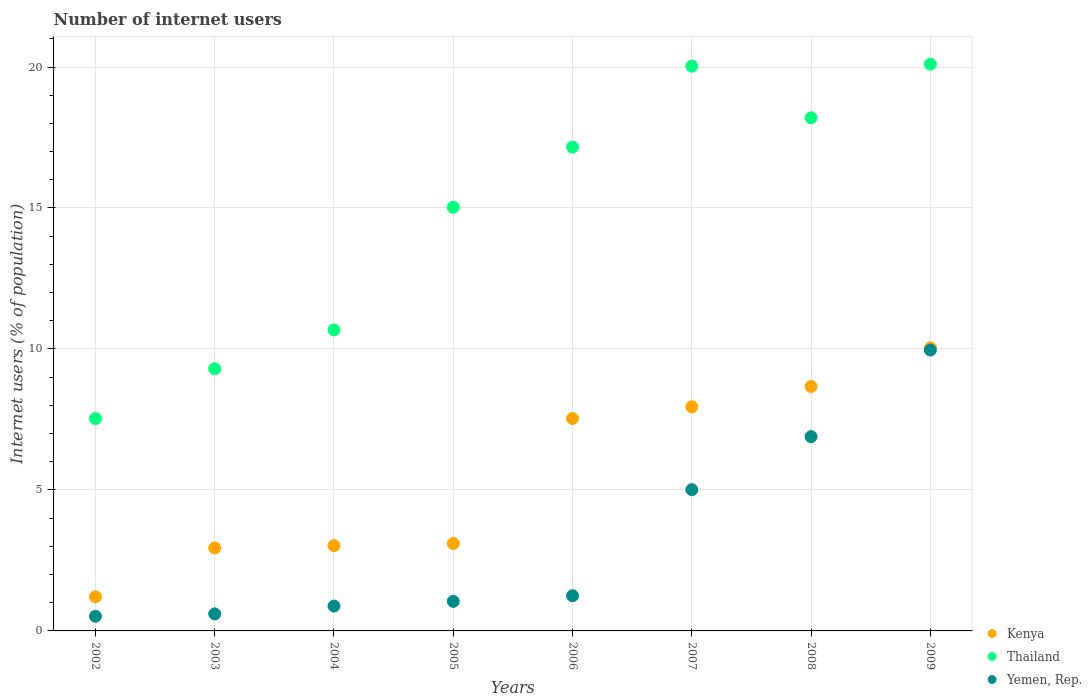How many different coloured dotlines are there?
Give a very brief answer. 3. Is the number of dotlines equal to the number of legend labels?
Ensure brevity in your answer.  Yes. What is the number of internet users in Kenya in 2009?
Your response must be concise. 10.04. Across all years, what is the maximum number of internet users in Kenya?
Your answer should be compact. 10.04. Across all years, what is the minimum number of internet users in Thailand?
Your answer should be compact. 7.53. What is the total number of internet users in Thailand in the graph?
Give a very brief answer. 118.02. What is the difference between the number of internet users in Yemen, Rep. in 2004 and that in 2007?
Provide a short and direct response. -4.13. What is the difference between the number of internet users in Thailand in 2009 and the number of internet users in Yemen, Rep. in 2007?
Your answer should be compact. 15.09. What is the average number of internet users in Yemen, Rep. per year?
Keep it short and to the point. 3.27. In the year 2008, what is the difference between the number of internet users in Yemen, Rep. and number of internet users in Kenya?
Your answer should be very brief. -1.78. What is the ratio of the number of internet users in Yemen, Rep. in 2007 to that in 2008?
Keep it short and to the point. 0.73. Is the number of internet users in Yemen, Rep. in 2007 less than that in 2008?
Offer a terse response. Yes. Is the difference between the number of internet users in Yemen, Rep. in 2007 and 2008 greater than the difference between the number of internet users in Kenya in 2007 and 2008?
Offer a very short reply. No. What is the difference between the highest and the second highest number of internet users in Yemen, Rep.?
Provide a succinct answer. 3.07. What is the difference between the highest and the lowest number of internet users in Yemen, Rep.?
Offer a very short reply. 9.44. In how many years, is the number of internet users in Thailand greater than the average number of internet users in Thailand taken over all years?
Ensure brevity in your answer.  5. Does the number of internet users in Thailand monotonically increase over the years?
Provide a succinct answer. No. Is the number of internet users in Yemen, Rep. strictly greater than the number of internet users in Kenya over the years?
Your answer should be compact. No. Is the number of internet users in Thailand strictly less than the number of internet users in Kenya over the years?
Your response must be concise. No. How many dotlines are there?
Make the answer very short. 3. How many years are there in the graph?
Ensure brevity in your answer.  8. What is the difference between two consecutive major ticks on the Y-axis?
Your answer should be very brief. 5. Does the graph contain any zero values?
Offer a terse response. No. Where does the legend appear in the graph?
Your response must be concise. Bottom right. What is the title of the graph?
Provide a succinct answer. Number of internet users. What is the label or title of the X-axis?
Provide a short and direct response. Years. What is the label or title of the Y-axis?
Your answer should be very brief. Internet users (% of population). What is the Internet users (% of population) of Kenya in 2002?
Provide a succinct answer. 1.21. What is the Internet users (% of population) in Thailand in 2002?
Your answer should be very brief. 7.53. What is the Internet users (% of population) of Yemen, Rep. in 2002?
Your response must be concise. 0.52. What is the Internet users (% of population) in Kenya in 2003?
Your answer should be compact. 2.94. What is the Internet users (% of population) in Thailand in 2003?
Offer a very short reply. 9.3. What is the Internet users (% of population) in Yemen, Rep. in 2003?
Your answer should be compact. 0.6. What is the Internet users (% of population) of Kenya in 2004?
Provide a succinct answer. 3.02. What is the Internet users (% of population) of Thailand in 2004?
Give a very brief answer. 10.68. What is the Internet users (% of population) in Yemen, Rep. in 2004?
Keep it short and to the point. 0.88. What is the Internet users (% of population) of Kenya in 2005?
Your answer should be very brief. 3.1. What is the Internet users (% of population) in Thailand in 2005?
Keep it short and to the point. 15.03. What is the Internet users (% of population) of Yemen, Rep. in 2005?
Give a very brief answer. 1.05. What is the Internet users (% of population) in Kenya in 2006?
Your answer should be very brief. 7.53. What is the Internet users (% of population) in Thailand in 2006?
Provide a succinct answer. 17.16. What is the Internet users (% of population) of Yemen, Rep. in 2006?
Give a very brief answer. 1.25. What is the Internet users (% of population) in Kenya in 2007?
Your answer should be compact. 7.95. What is the Internet users (% of population) of Thailand in 2007?
Your answer should be compact. 20.03. What is the Internet users (% of population) in Yemen, Rep. in 2007?
Ensure brevity in your answer.  5.01. What is the Internet users (% of population) in Kenya in 2008?
Your response must be concise. 8.67. What is the Internet users (% of population) in Yemen, Rep. in 2008?
Keep it short and to the point. 6.89. What is the Internet users (% of population) in Kenya in 2009?
Provide a short and direct response. 10.04. What is the Internet users (% of population) in Thailand in 2009?
Offer a terse response. 20.1. What is the Internet users (% of population) in Yemen, Rep. in 2009?
Provide a succinct answer. 9.96. Across all years, what is the maximum Internet users (% of population) of Kenya?
Provide a succinct answer. 10.04. Across all years, what is the maximum Internet users (% of population) in Thailand?
Your answer should be very brief. 20.1. Across all years, what is the maximum Internet users (% of population) of Yemen, Rep.?
Make the answer very short. 9.96. Across all years, what is the minimum Internet users (% of population) in Kenya?
Your answer should be very brief. 1.21. Across all years, what is the minimum Internet users (% of population) of Thailand?
Provide a succinct answer. 7.53. Across all years, what is the minimum Internet users (% of population) in Yemen, Rep.?
Provide a succinct answer. 0.52. What is the total Internet users (% of population) of Kenya in the graph?
Ensure brevity in your answer.  44.47. What is the total Internet users (% of population) in Thailand in the graph?
Ensure brevity in your answer.  118.02. What is the total Internet users (% of population) in Yemen, Rep. in the graph?
Your answer should be compact. 26.16. What is the difference between the Internet users (% of population) of Kenya in 2002 and that in 2003?
Offer a terse response. -1.73. What is the difference between the Internet users (% of population) of Thailand in 2002 and that in 2003?
Offer a very short reply. -1.77. What is the difference between the Internet users (% of population) of Yemen, Rep. in 2002 and that in 2003?
Provide a succinct answer. -0.09. What is the difference between the Internet users (% of population) in Kenya in 2002 and that in 2004?
Your response must be concise. -1.82. What is the difference between the Internet users (% of population) of Thailand in 2002 and that in 2004?
Ensure brevity in your answer.  -3.15. What is the difference between the Internet users (% of population) of Yemen, Rep. in 2002 and that in 2004?
Keep it short and to the point. -0.36. What is the difference between the Internet users (% of population) in Kenya in 2002 and that in 2005?
Provide a succinct answer. -1.89. What is the difference between the Internet users (% of population) in Thailand in 2002 and that in 2005?
Make the answer very short. -7.49. What is the difference between the Internet users (% of population) in Yemen, Rep. in 2002 and that in 2005?
Your answer should be very brief. -0.53. What is the difference between the Internet users (% of population) in Kenya in 2002 and that in 2006?
Your answer should be compact. -6.33. What is the difference between the Internet users (% of population) of Thailand in 2002 and that in 2006?
Provide a succinct answer. -9.63. What is the difference between the Internet users (% of population) in Yemen, Rep. in 2002 and that in 2006?
Ensure brevity in your answer.  -0.73. What is the difference between the Internet users (% of population) in Kenya in 2002 and that in 2007?
Provide a short and direct response. -6.74. What is the difference between the Internet users (% of population) in Thailand in 2002 and that in 2007?
Offer a very short reply. -12.5. What is the difference between the Internet users (% of population) in Yemen, Rep. in 2002 and that in 2007?
Your answer should be compact. -4.49. What is the difference between the Internet users (% of population) of Kenya in 2002 and that in 2008?
Make the answer very short. -7.46. What is the difference between the Internet users (% of population) in Thailand in 2002 and that in 2008?
Your answer should be very brief. -10.67. What is the difference between the Internet users (% of population) in Yemen, Rep. in 2002 and that in 2008?
Your response must be concise. -6.37. What is the difference between the Internet users (% of population) of Kenya in 2002 and that in 2009?
Give a very brief answer. -8.83. What is the difference between the Internet users (% of population) in Thailand in 2002 and that in 2009?
Provide a short and direct response. -12.57. What is the difference between the Internet users (% of population) of Yemen, Rep. in 2002 and that in 2009?
Keep it short and to the point. -9.44. What is the difference between the Internet users (% of population) of Kenya in 2003 and that in 2004?
Your answer should be very brief. -0.08. What is the difference between the Internet users (% of population) of Thailand in 2003 and that in 2004?
Give a very brief answer. -1.38. What is the difference between the Internet users (% of population) in Yemen, Rep. in 2003 and that in 2004?
Make the answer very short. -0.28. What is the difference between the Internet users (% of population) of Kenya in 2003 and that in 2005?
Keep it short and to the point. -0.16. What is the difference between the Internet users (% of population) in Thailand in 2003 and that in 2005?
Make the answer very short. -5.73. What is the difference between the Internet users (% of population) of Yemen, Rep. in 2003 and that in 2005?
Your response must be concise. -0.44. What is the difference between the Internet users (% of population) of Kenya in 2003 and that in 2006?
Ensure brevity in your answer.  -4.59. What is the difference between the Internet users (% of population) of Thailand in 2003 and that in 2006?
Give a very brief answer. -7.86. What is the difference between the Internet users (% of population) in Yemen, Rep. in 2003 and that in 2006?
Keep it short and to the point. -0.64. What is the difference between the Internet users (% of population) in Kenya in 2003 and that in 2007?
Ensure brevity in your answer.  -5.01. What is the difference between the Internet users (% of population) in Thailand in 2003 and that in 2007?
Offer a terse response. -10.73. What is the difference between the Internet users (% of population) of Yemen, Rep. in 2003 and that in 2007?
Your response must be concise. -4.41. What is the difference between the Internet users (% of population) in Kenya in 2003 and that in 2008?
Your answer should be very brief. -5.73. What is the difference between the Internet users (% of population) in Thailand in 2003 and that in 2008?
Ensure brevity in your answer.  -8.9. What is the difference between the Internet users (% of population) of Yemen, Rep. in 2003 and that in 2008?
Provide a succinct answer. -6.29. What is the difference between the Internet users (% of population) of Kenya in 2003 and that in 2009?
Your response must be concise. -7.1. What is the difference between the Internet users (% of population) in Thailand in 2003 and that in 2009?
Give a very brief answer. -10.8. What is the difference between the Internet users (% of population) in Yemen, Rep. in 2003 and that in 2009?
Ensure brevity in your answer.  -9.36. What is the difference between the Internet users (% of population) in Kenya in 2004 and that in 2005?
Provide a short and direct response. -0.08. What is the difference between the Internet users (% of population) of Thailand in 2004 and that in 2005?
Keep it short and to the point. -4.35. What is the difference between the Internet users (% of population) in Yemen, Rep. in 2004 and that in 2005?
Keep it short and to the point. -0.17. What is the difference between the Internet users (% of population) of Kenya in 2004 and that in 2006?
Offer a very short reply. -4.51. What is the difference between the Internet users (% of population) of Thailand in 2004 and that in 2006?
Ensure brevity in your answer.  -6.48. What is the difference between the Internet users (% of population) in Yemen, Rep. in 2004 and that in 2006?
Make the answer very short. -0.37. What is the difference between the Internet users (% of population) in Kenya in 2004 and that in 2007?
Make the answer very short. -4.93. What is the difference between the Internet users (% of population) in Thailand in 2004 and that in 2007?
Your answer should be compact. -9.35. What is the difference between the Internet users (% of population) in Yemen, Rep. in 2004 and that in 2007?
Your answer should be compact. -4.13. What is the difference between the Internet users (% of population) of Kenya in 2004 and that in 2008?
Ensure brevity in your answer.  -5.65. What is the difference between the Internet users (% of population) in Thailand in 2004 and that in 2008?
Your answer should be compact. -7.52. What is the difference between the Internet users (% of population) of Yemen, Rep. in 2004 and that in 2008?
Keep it short and to the point. -6.01. What is the difference between the Internet users (% of population) in Kenya in 2004 and that in 2009?
Offer a very short reply. -7.02. What is the difference between the Internet users (% of population) in Thailand in 2004 and that in 2009?
Keep it short and to the point. -9.42. What is the difference between the Internet users (% of population) in Yemen, Rep. in 2004 and that in 2009?
Ensure brevity in your answer.  -9.08. What is the difference between the Internet users (% of population) in Kenya in 2005 and that in 2006?
Provide a succinct answer. -4.43. What is the difference between the Internet users (% of population) of Thailand in 2005 and that in 2006?
Provide a short and direct response. -2.13. What is the difference between the Internet users (% of population) in Yemen, Rep. in 2005 and that in 2006?
Provide a short and direct response. -0.2. What is the difference between the Internet users (% of population) of Kenya in 2005 and that in 2007?
Give a very brief answer. -4.85. What is the difference between the Internet users (% of population) in Thailand in 2005 and that in 2007?
Offer a terse response. -5. What is the difference between the Internet users (% of population) in Yemen, Rep. in 2005 and that in 2007?
Ensure brevity in your answer.  -3.96. What is the difference between the Internet users (% of population) in Kenya in 2005 and that in 2008?
Provide a short and direct response. -5.57. What is the difference between the Internet users (% of population) in Thailand in 2005 and that in 2008?
Provide a succinct answer. -3.17. What is the difference between the Internet users (% of population) in Yemen, Rep. in 2005 and that in 2008?
Offer a very short reply. -5.84. What is the difference between the Internet users (% of population) in Kenya in 2005 and that in 2009?
Provide a succinct answer. -6.94. What is the difference between the Internet users (% of population) in Thailand in 2005 and that in 2009?
Offer a terse response. -5.07. What is the difference between the Internet users (% of population) in Yemen, Rep. in 2005 and that in 2009?
Give a very brief answer. -8.91. What is the difference between the Internet users (% of population) in Kenya in 2006 and that in 2007?
Provide a succinct answer. -0.42. What is the difference between the Internet users (% of population) of Thailand in 2006 and that in 2007?
Your answer should be very brief. -2.87. What is the difference between the Internet users (% of population) in Yemen, Rep. in 2006 and that in 2007?
Your answer should be compact. -3.76. What is the difference between the Internet users (% of population) of Kenya in 2006 and that in 2008?
Offer a very short reply. -1.14. What is the difference between the Internet users (% of population) in Thailand in 2006 and that in 2008?
Keep it short and to the point. -1.04. What is the difference between the Internet users (% of population) in Yemen, Rep. in 2006 and that in 2008?
Ensure brevity in your answer.  -5.64. What is the difference between the Internet users (% of population) of Kenya in 2006 and that in 2009?
Give a very brief answer. -2.51. What is the difference between the Internet users (% of population) of Thailand in 2006 and that in 2009?
Ensure brevity in your answer.  -2.94. What is the difference between the Internet users (% of population) of Yemen, Rep. in 2006 and that in 2009?
Provide a short and direct response. -8.71. What is the difference between the Internet users (% of population) of Kenya in 2007 and that in 2008?
Offer a terse response. -0.72. What is the difference between the Internet users (% of population) in Thailand in 2007 and that in 2008?
Give a very brief answer. 1.83. What is the difference between the Internet users (% of population) in Yemen, Rep. in 2007 and that in 2008?
Make the answer very short. -1.88. What is the difference between the Internet users (% of population) of Kenya in 2007 and that in 2009?
Offer a terse response. -2.09. What is the difference between the Internet users (% of population) in Thailand in 2007 and that in 2009?
Provide a succinct answer. -0.07. What is the difference between the Internet users (% of population) of Yemen, Rep. in 2007 and that in 2009?
Offer a terse response. -4.95. What is the difference between the Internet users (% of population) of Kenya in 2008 and that in 2009?
Ensure brevity in your answer.  -1.37. What is the difference between the Internet users (% of population) of Thailand in 2008 and that in 2009?
Make the answer very short. -1.9. What is the difference between the Internet users (% of population) in Yemen, Rep. in 2008 and that in 2009?
Provide a succinct answer. -3.07. What is the difference between the Internet users (% of population) in Kenya in 2002 and the Internet users (% of population) in Thailand in 2003?
Offer a very short reply. -8.09. What is the difference between the Internet users (% of population) of Kenya in 2002 and the Internet users (% of population) of Yemen, Rep. in 2003?
Ensure brevity in your answer.  0.6. What is the difference between the Internet users (% of population) of Thailand in 2002 and the Internet users (% of population) of Yemen, Rep. in 2003?
Offer a very short reply. 6.93. What is the difference between the Internet users (% of population) in Kenya in 2002 and the Internet users (% of population) in Thailand in 2004?
Ensure brevity in your answer.  -9.47. What is the difference between the Internet users (% of population) in Kenya in 2002 and the Internet users (% of population) in Yemen, Rep. in 2004?
Make the answer very short. 0.33. What is the difference between the Internet users (% of population) of Thailand in 2002 and the Internet users (% of population) of Yemen, Rep. in 2004?
Your answer should be very brief. 6.65. What is the difference between the Internet users (% of population) in Kenya in 2002 and the Internet users (% of population) in Thailand in 2005?
Offer a terse response. -13.82. What is the difference between the Internet users (% of population) of Kenya in 2002 and the Internet users (% of population) of Yemen, Rep. in 2005?
Ensure brevity in your answer.  0.16. What is the difference between the Internet users (% of population) in Thailand in 2002 and the Internet users (% of population) in Yemen, Rep. in 2005?
Your answer should be compact. 6.48. What is the difference between the Internet users (% of population) of Kenya in 2002 and the Internet users (% of population) of Thailand in 2006?
Your answer should be very brief. -15.95. What is the difference between the Internet users (% of population) of Kenya in 2002 and the Internet users (% of population) of Yemen, Rep. in 2006?
Offer a very short reply. -0.04. What is the difference between the Internet users (% of population) in Thailand in 2002 and the Internet users (% of population) in Yemen, Rep. in 2006?
Ensure brevity in your answer.  6.28. What is the difference between the Internet users (% of population) of Kenya in 2002 and the Internet users (% of population) of Thailand in 2007?
Make the answer very short. -18.82. What is the difference between the Internet users (% of population) in Kenya in 2002 and the Internet users (% of population) in Yemen, Rep. in 2007?
Make the answer very short. -3.8. What is the difference between the Internet users (% of population) of Thailand in 2002 and the Internet users (% of population) of Yemen, Rep. in 2007?
Your response must be concise. 2.52. What is the difference between the Internet users (% of population) of Kenya in 2002 and the Internet users (% of population) of Thailand in 2008?
Your answer should be very brief. -16.99. What is the difference between the Internet users (% of population) in Kenya in 2002 and the Internet users (% of population) in Yemen, Rep. in 2008?
Provide a short and direct response. -5.68. What is the difference between the Internet users (% of population) in Thailand in 2002 and the Internet users (% of population) in Yemen, Rep. in 2008?
Offer a terse response. 0.64. What is the difference between the Internet users (% of population) of Kenya in 2002 and the Internet users (% of population) of Thailand in 2009?
Provide a short and direct response. -18.89. What is the difference between the Internet users (% of population) of Kenya in 2002 and the Internet users (% of population) of Yemen, Rep. in 2009?
Provide a short and direct response. -8.75. What is the difference between the Internet users (% of population) in Thailand in 2002 and the Internet users (% of population) in Yemen, Rep. in 2009?
Your answer should be very brief. -2.43. What is the difference between the Internet users (% of population) of Kenya in 2003 and the Internet users (% of population) of Thailand in 2004?
Your answer should be very brief. -7.74. What is the difference between the Internet users (% of population) of Kenya in 2003 and the Internet users (% of population) of Yemen, Rep. in 2004?
Ensure brevity in your answer.  2.06. What is the difference between the Internet users (% of population) in Thailand in 2003 and the Internet users (% of population) in Yemen, Rep. in 2004?
Your answer should be very brief. 8.42. What is the difference between the Internet users (% of population) in Kenya in 2003 and the Internet users (% of population) in Thailand in 2005?
Make the answer very short. -12.08. What is the difference between the Internet users (% of population) in Kenya in 2003 and the Internet users (% of population) in Yemen, Rep. in 2005?
Make the answer very short. 1.89. What is the difference between the Internet users (% of population) of Thailand in 2003 and the Internet users (% of population) of Yemen, Rep. in 2005?
Your response must be concise. 8.25. What is the difference between the Internet users (% of population) of Kenya in 2003 and the Internet users (% of population) of Thailand in 2006?
Ensure brevity in your answer.  -14.22. What is the difference between the Internet users (% of population) in Kenya in 2003 and the Internet users (% of population) in Yemen, Rep. in 2006?
Keep it short and to the point. 1.69. What is the difference between the Internet users (% of population) of Thailand in 2003 and the Internet users (% of population) of Yemen, Rep. in 2006?
Offer a very short reply. 8.05. What is the difference between the Internet users (% of population) of Kenya in 2003 and the Internet users (% of population) of Thailand in 2007?
Provide a short and direct response. -17.09. What is the difference between the Internet users (% of population) of Kenya in 2003 and the Internet users (% of population) of Yemen, Rep. in 2007?
Offer a very short reply. -2.07. What is the difference between the Internet users (% of population) of Thailand in 2003 and the Internet users (% of population) of Yemen, Rep. in 2007?
Ensure brevity in your answer.  4.29. What is the difference between the Internet users (% of population) of Kenya in 2003 and the Internet users (% of population) of Thailand in 2008?
Your response must be concise. -15.26. What is the difference between the Internet users (% of population) of Kenya in 2003 and the Internet users (% of population) of Yemen, Rep. in 2008?
Ensure brevity in your answer.  -3.95. What is the difference between the Internet users (% of population) in Thailand in 2003 and the Internet users (% of population) in Yemen, Rep. in 2008?
Your response must be concise. 2.41. What is the difference between the Internet users (% of population) of Kenya in 2003 and the Internet users (% of population) of Thailand in 2009?
Your response must be concise. -17.16. What is the difference between the Internet users (% of population) in Kenya in 2003 and the Internet users (% of population) in Yemen, Rep. in 2009?
Provide a short and direct response. -7.02. What is the difference between the Internet users (% of population) in Thailand in 2003 and the Internet users (% of population) in Yemen, Rep. in 2009?
Give a very brief answer. -0.66. What is the difference between the Internet users (% of population) in Kenya in 2004 and the Internet users (% of population) in Thailand in 2005?
Provide a succinct answer. -12. What is the difference between the Internet users (% of population) in Kenya in 2004 and the Internet users (% of population) in Yemen, Rep. in 2005?
Your response must be concise. 1.97. What is the difference between the Internet users (% of population) in Thailand in 2004 and the Internet users (% of population) in Yemen, Rep. in 2005?
Make the answer very short. 9.63. What is the difference between the Internet users (% of population) of Kenya in 2004 and the Internet users (% of population) of Thailand in 2006?
Your answer should be compact. -14.14. What is the difference between the Internet users (% of population) in Kenya in 2004 and the Internet users (% of population) in Yemen, Rep. in 2006?
Keep it short and to the point. 1.78. What is the difference between the Internet users (% of population) of Thailand in 2004 and the Internet users (% of population) of Yemen, Rep. in 2006?
Provide a succinct answer. 9.43. What is the difference between the Internet users (% of population) in Kenya in 2004 and the Internet users (% of population) in Thailand in 2007?
Your response must be concise. -17.01. What is the difference between the Internet users (% of population) in Kenya in 2004 and the Internet users (% of population) in Yemen, Rep. in 2007?
Your answer should be compact. -1.99. What is the difference between the Internet users (% of population) of Thailand in 2004 and the Internet users (% of population) of Yemen, Rep. in 2007?
Provide a short and direct response. 5.67. What is the difference between the Internet users (% of population) in Kenya in 2004 and the Internet users (% of population) in Thailand in 2008?
Your answer should be very brief. -15.18. What is the difference between the Internet users (% of population) in Kenya in 2004 and the Internet users (% of population) in Yemen, Rep. in 2008?
Your response must be concise. -3.87. What is the difference between the Internet users (% of population) in Thailand in 2004 and the Internet users (% of population) in Yemen, Rep. in 2008?
Provide a short and direct response. 3.79. What is the difference between the Internet users (% of population) in Kenya in 2004 and the Internet users (% of population) in Thailand in 2009?
Give a very brief answer. -17.08. What is the difference between the Internet users (% of population) of Kenya in 2004 and the Internet users (% of population) of Yemen, Rep. in 2009?
Offer a terse response. -6.94. What is the difference between the Internet users (% of population) of Thailand in 2004 and the Internet users (% of population) of Yemen, Rep. in 2009?
Make the answer very short. 0.72. What is the difference between the Internet users (% of population) of Kenya in 2005 and the Internet users (% of population) of Thailand in 2006?
Your answer should be compact. -14.06. What is the difference between the Internet users (% of population) of Kenya in 2005 and the Internet users (% of population) of Yemen, Rep. in 2006?
Keep it short and to the point. 1.85. What is the difference between the Internet users (% of population) of Thailand in 2005 and the Internet users (% of population) of Yemen, Rep. in 2006?
Offer a terse response. 13.78. What is the difference between the Internet users (% of population) in Kenya in 2005 and the Internet users (% of population) in Thailand in 2007?
Give a very brief answer. -16.93. What is the difference between the Internet users (% of population) of Kenya in 2005 and the Internet users (% of population) of Yemen, Rep. in 2007?
Offer a terse response. -1.91. What is the difference between the Internet users (% of population) in Thailand in 2005 and the Internet users (% of population) in Yemen, Rep. in 2007?
Provide a succinct answer. 10.02. What is the difference between the Internet users (% of population) of Kenya in 2005 and the Internet users (% of population) of Thailand in 2008?
Your answer should be very brief. -15.1. What is the difference between the Internet users (% of population) in Kenya in 2005 and the Internet users (% of population) in Yemen, Rep. in 2008?
Make the answer very short. -3.79. What is the difference between the Internet users (% of population) of Thailand in 2005 and the Internet users (% of population) of Yemen, Rep. in 2008?
Your answer should be compact. 8.14. What is the difference between the Internet users (% of population) in Kenya in 2005 and the Internet users (% of population) in Thailand in 2009?
Your response must be concise. -17. What is the difference between the Internet users (% of population) in Kenya in 2005 and the Internet users (% of population) in Yemen, Rep. in 2009?
Provide a short and direct response. -6.86. What is the difference between the Internet users (% of population) of Thailand in 2005 and the Internet users (% of population) of Yemen, Rep. in 2009?
Make the answer very short. 5.07. What is the difference between the Internet users (% of population) in Kenya in 2006 and the Internet users (% of population) in Thailand in 2007?
Provide a succinct answer. -12.5. What is the difference between the Internet users (% of population) of Kenya in 2006 and the Internet users (% of population) of Yemen, Rep. in 2007?
Make the answer very short. 2.52. What is the difference between the Internet users (% of population) in Thailand in 2006 and the Internet users (% of population) in Yemen, Rep. in 2007?
Give a very brief answer. 12.15. What is the difference between the Internet users (% of population) in Kenya in 2006 and the Internet users (% of population) in Thailand in 2008?
Keep it short and to the point. -10.67. What is the difference between the Internet users (% of population) in Kenya in 2006 and the Internet users (% of population) in Yemen, Rep. in 2008?
Ensure brevity in your answer.  0.64. What is the difference between the Internet users (% of population) in Thailand in 2006 and the Internet users (% of population) in Yemen, Rep. in 2008?
Your answer should be compact. 10.27. What is the difference between the Internet users (% of population) of Kenya in 2006 and the Internet users (% of population) of Thailand in 2009?
Offer a very short reply. -12.57. What is the difference between the Internet users (% of population) of Kenya in 2006 and the Internet users (% of population) of Yemen, Rep. in 2009?
Keep it short and to the point. -2.43. What is the difference between the Internet users (% of population) of Thailand in 2006 and the Internet users (% of population) of Yemen, Rep. in 2009?
Give a very brief answer. 7.2. What is the difference between the Internet users (% of population) of Kenya in 2007 and the Internet users (% of population) of Thailand in 2008?
Provide a short and direct response. -10.25. What is the difference between the Internet users (% of population) of Kenya in 2007 and the Internet users (% of population) of Yemen, Rep. in 2008?
Give a very brief answer. 1.06. What is the difference between the Internet users (% of population) in Thailand in 2007 and the Internet users (% of population) in Yemen, Rep. in 2008?
Provide a succinct answer. 13.14. What is the difference between the Internet users (% of population) in Kenya in 2007 and the Internet users (% of population) in Thailand in 2009?
Offer a terse response. -12.15. What is the difference between the Internet users (% of population) in Kenya in 2007 and the Internet users (% of population) in Yemen, Rep. in 2009?
Offer a terse response. -2.01. What is the difference between the Internet users (% of population) of Thailand in 2007 and the Internet users (% of population) of Yemen, Rep. in 2009?
Make the answer very short. 10.07. What is the difference between the Internet users (% of population) of Kenya in 2008 and the Internet users (% of population) of Thailand in 2009?
Your answer should be compact. -11.43. What is the difference between the Internet users (% of population) of Kenya in 2008 and the Internet users (% of population) of Yemen, Rep. in 2009?
Give a very brief answer. -1.29. What is the difference between the Internet users (% of population) in Thailand in 2008 and the Internet users (% of population) in Yemen, Rep. in 2009?
Your response must be concise. 8.24. What is the average Internet users (% of population) of Kenya per year?
Ensure brevity in your answer.  5.56. What is the average Internet users (% of population) of Thailand per year?
Provide a succinct answer. 14.75. What is the average Internet users (% of population) of Yemen, Rep. per year?
Offer a terse response. 3.27. In the year 2002, what is the difference between the Internet users (% of population) of Kenya and Internet users (% of population) of Thailand?
Offer a terse response. -6.32. In the year 2002, what is the difference between the Internet users (% of population) of Kenya and Internet users (% of population) of Yemen, Rep.?
Your answer should be compact. 0.69. In the year 2002, what is the difference between the Internet users (% of population) in Thailand and Internet users (% of population) in Yemen, Rep.?
Provide a succinct answer. 7.01. In the year 2003, what is the difference between the Internet users (% of population) of Kenya and Internet users (% of population) of Thailand?
Keep it short and to the point. -6.36. In the year 2003, what is the difference between the Internet users (% of population) of Kenya and Internet users (% of population) of Yemen, Rep.?
Offer a terse response. 2.34. In the year 2003, what is the difference between the Internet users (% of population) in Thailand and Internet users (% of population) in Yemen, Rep.?
Your answer should be compact. 8.69. In the year 2004, what is the difference between the Internet users (% of population) in Kenya and Internet users (% of population) in Thailand?
Provide a short and direct response. -7.65. In the year 2004, what is the difference between the Internet users (% of population) of Kenya and Internet users (% of population) of Yemen, Rep.?
Offer a terse response. 2.14. In the year 2004, what is the difference between the Internet users (% of population) in Thailand and Internet users (% of population) in Yemen, Rep.?
Your answer should be compact. 9.8. In the year 2005, what is the difference between the Internet users (% of population) in Kenya and Internet users (% of population) in Thailand?
Ensure brevity in your answer.  -11.92. In the year 2005, what is the difference between the Internet users (% of population) of Kenya and Internet users (% of population) of Yemen, Rep.?
Keep it short and to the point. 2.05. In the year 2005, what is the difference between the Internet users (% of population) of Thailand and Internet users (% of population) of Yemen, Rep.?
Your answer should be very brief. 13.98. In the year 2006, what is the difference between the Internet users (% of population) in Kenya and Internet users (% of population) in Thailand?
Offer a very short reply. -9.63. In the year 2006, what is the difference between the Internet users (% of population) of Kenya and Internet users (% of population) of Yemen, Rep.?
Ensure brevity in your answer.  6.29. In the year 2006, what is the difference between the Internet users (% of population) in Thailand and Internet users (% of population) in Yemen, Rep.?
Make the answer very short. 15.91. In the year 2007, what is the difference between the Internet users (% of population) in Kenya and Internet users (% of population) in Thailand?
Give a very brief answer. -12.08. In the year 2007, what is the difference between the Internet users (% of population) in Kenya and Internet users (% of population) in Yemen, Rep.?
Make the answer very short. 2.94. In the year 2007, what is the difference between the Internet users (% of population) of Thailand and Internet users (% of population) of Yemen, Rep.?
Your answer should be very brief. 15.02. In the year 2008, what is the difference between the Internet users (% of population) of Kenya and Internet users (% of population) of Thailand?
Provide a succinct answer. -9.53. In the year 2008, what is the difference between the Internet users (% of population) in Kenya and Internet users (% of population) in Yemen, Rep.?
Offer a very short reply. 1.78. In the year 2008, what is the difference between the Internet users (% of population) in Thailand and Internet users (% of population) in Yemen, Rep.?
Offer a terse response. 11.31. In the year 2009, what is the difference between the Internet users (% of population) in Kenya and Internet users (% of population) in Thailand?
Ensure brevity in your answer.  -10.06. In the year 2009, what is the difference between the Internet users (% of population) of Thailand and Internet users (% of population) of Yemen, Rep.?
Offer a terse response. 10.14. What is the ratio of the Internet users (% of population) in Kenya in 2002 to that in 2003?
Give a very brief answer. 0.41. What is the ratio of the Internet users (% of population) in Thailand in 2002 to that in 2003?
Provide a short and direct response. 0.81. What is the ratio of the Internet users (% of population) in Yemen, Rep. in 2002 to that in 2003?
Offer a very short reply. 0.86. What is the ratio of the Internet users (% of population) in Kenya in 2002 to that in 2004?
Offer a very short reply. 0.4. What is the ratio of the Internet users (% of population) in Thailand in 2002 to that in 2004?
Offer a terse response. 0.71. What is the ratio of the Internet users (% of population) in Yemen, Rep. in 2002 to that in 2004?
Make the answer very short. 0.59. What is the ratio of the Internet users (% of population) in Kenya in 2002 to that in 2005?
Make the answer very short. 0.39. What is the ratio of the Internet users (% of population) in Thailand in 2002 to that in 2005?
Provide a short and direct response. 0.5. What is the ratio of the Internet users (% of population) of Yemen, Rep. in 2002 to that in 2005?
Provide a short and direct response. 0.49. What is the ratio of the Internet users (% of population) in Kenya in 2002 to that in 2006?
Give a very brief answer. 0.16. What is the ratio of the Internet users (% of population) in Thailand in 2002 to that in 2006?
Offer a very short reply. 0.44. What is the ratio of the Internet users (% of population) of Yemen, Rep. in 2002 to that in 2006?
Your answer should be very brief. 0.42. What is the ratio of the Internet users (% of population) of Kenya in 2002 to that in 2007?
Ensure brevity in your answer.  0.15. What is the ratio of the Internet users (% of population) in Thailand in 2002 to that in 2007?
Give a very brief answer. 0.38. What is the ratio of the Internet users (% of population) in Yemen, Rep. in 2002 to that in 2007?
Offer a very short reply. 0.1. What is the ratio of the Internet users (% of population) of Kenya in 2002 to that in 2008?
Give a very brief answer. 0.14. What is the ratio of the Internet users (% of population) in Thailand in 2002 to that in 2008?
Your answer should be very brief. 0.41. What is the ratio of the Internet users (% of population) of Yemen, Rep. in 2002 to that in 2008?
Keep it short and to the point. 0.08. What is the ratio of the Internet users (% of population) of Kenya in 2002 to that in 2009?
Provide a short and direct response. 0.12. What is the ratio of the Internet users (% of population) in Thailand in 2002 to that in 2009?
Provide a short and direct response. 0.37. What is the ratio of the Internet users (% of population) in Yemen, Rep. in 2002 to that in 2009?
Provide a succinct answer. 0.05. What is the ratio of the Internet users (% of population) in Thailand in 2003 to that in 2004?
Provide a succinct answer. 0.87. What is the ratio of the Internet users (% of population) in Yemen, Rep. in 2003 to that in 2004?
Provide a short and direct response. 0.69. What is the ratio of the Internet users (% of population) in Kenya in 2003 to that in 2005?
Your response must be concise. 0.95. What is the ratio of the Internet users (% of population) in Thailand in 2003 to that in 2005?
Your response must be concise. 0.62. What is the ratio of the Internet users (% of population) in Yemen, Rep. in 2003 to that in 2005?
Your answer should be compact. 0.58. What is the ratio of the Internet users (% of population) of Kenya in 2003 to that in 2006?
Offer a very short reply. 0.39. What is the ratio of the Internet users (% of population) in Thailand in 2003 to that in 2006?
Ensure brevity in your answer.  0.54. What is the ratio of the Internet users (% of population) in Yemen, Rep. in 2003 to that in 2006?
Keep it short and to the point. 0.48. What is the ratio of the Internet users (% of population) of Kenya in 2003 to that in 2007?
Your response must be concise. 0.37. What is the ratio of the Internet users (% of population) in Thailand in 2003 to that in 2007?
Provide a short and direct response. 0.46. What is the ratio of the Internet users (% of population) of Yemen, Rep. in 2003 to that in 2007?
Provide a short and direct response. 0.12. What is the ratio of the Internet users (% of population) in Kenya in 2003 to that in 2008?
Your answer should be very brief. 0.34. What is the ratio of the Internet users (% of population) in Thailand in 2003 to that in 2008?
Ensure brevity in your answer.  0.51. What is the ratio of the Internet users (% of population) in Yemen, Rep. in 2003 to that in 2008?
Provide a short and direct response. 0.09. What is the ratio of the Internet users (% of population) in Kenya in 2003 to that in 2009?
Offer a very short reply. 0.29. What is the ratio of the Internet users (% of population) of Thailand in 2003 to that in 2009?
Provide a short and direct response. 0.46. What is the ratio of the Internet users (% of population) of Yemen, Rep. in 2003 to that in 2009?
Keep it short and to the point. 0.06. What is the ratio of the Internet users (% of population) in Kenya in 2004 to that in 2005?
Your answer should be very brief. 0.97. What is the ratio of the Internet users (% of population) of Thailand in 2004 to that in 2005?
Your answer should be compact. 0.71. What is the ratio of the Internet users (% of population) in Yemen, Rep. in 2004 to that in 2005?
Your answer should be very brief. 0.84. What is the ratio of the Internet users (% of population) of Kenya in 2004 to that in 2006?
Make the answer very short. 0.4. What is the ratio of the Internet users (% of population) in Thailand in 2004 to that in 2006?
Your answer should be compact. 0.62. What is the ratio of the Internet users (% of population) in Yemen, Rep. in 2004 to that in 2006?
Your response must be concise. 0.71. What is the ratio of the Internet users (% of population) in Kenya in 2004 to that in 2007?
Give a very brief answer. 0.38. What is the ratio of the Internet users (% of population) in Thailand in 2004 to that in 2007?
Provide a short and direct response. 0.53. What is the ratio of the Internet users (% of population) of Yemen, Rep. in 2004 to that in 2007?
Your answer should be very brief. 0.18. What is the ratio of the Internet users (% of population) of Kenya in 2004 to that in 2008?
Provide a short and direct response. 0.35. What is the ratio of the Internet users (% of population) of Thailand in 2004 to that in 2008?
Your answer should be very brief. 0.59. What is the ratio of the Internet users (% of population) in Yemen, Rep. in 2004 to that in 2008?
Offer a very short reply. 0.13. What is the ratio of the Internet users (% of population) of Kenya in 2004 to that in 2009?
Make the answer very short. 0.3. What is the ratio of the Internet users (% of population) in Thailand in 2004 to that in 2009?
Give a very brief answer. 0.53. What is the ratio of the Internet users (% of population) of Yemen, Rep. in 2004 to that in 2009?
Your answer should be compact. 0.09. What is the ratio of the Internet users (% of population) of Kenya in 2005 to that in 2006?
Make the answer very short. 0.41. What is the ratio of the Internet users (% of population) in Thailand in 2005 to that in 2006?
Provide a succinct answer. 0.88. What is the ratio of the Internet users (% of population) in Yemen, Rep. in 2005 to that in 2006?
Offer a terse response. 0.84. What is the ratio of the Internet users (% of population) of Kenya in 2005 to that in 2007?
Make the answer very short. 0.39. What is the ratio of the Internet users (% of population) of Thailand in 2005 to that in 2007?
Your response must be concise. 0.75. What is the ratio of the Internet users (% of population) of Yemen, Rep. in 2005 to that in 2007?
Offer a terse response. 0.21. What is the ratio of the Internet users (% of population) in Kenya in 2005 to that in 2008?
Give a very brief answer. 0.36. What is the ratio of the Internet users (% of population) of Thailand in 2005 to that in 2008?
Keep it short and to the point. 0.83. What is the ratio of the Internet users (% of population) of Yemen, Rep. in 2005 to that in 2008?
Offer a terse response. 0.15. What is the ratio of the Internet users (% of population) in Kenya in 2005 to that in 2009?
Your answer should be very brief. 0.31. What is the ratio of the Internet users (% of population) in Thailand in 2005 to that in 2009?
Provide a succinct answer. 0.75. What is the ratio of the Internet users (% of population) of Yemen, Rep. in 2005 to that in 2009?
Your answer should be very brief. 0.11. What is the ratio of the Internet users (% of population) in Kenya in 2006 to that in 2007?
Your answer should be very brief. 0.95. What is the ratio of the Internet users (% of population) in Thailand in 2006 to that in 2007?
Give a very brief answer. 0.86. What is the ratio of the Internet users (% of population) of Yemen, Rep. in 2006 to that in 2007?
Provide a short and direct response. 0.25. What is the ratio of the Internet users (% of population) of Kenya in 2006 to that in 2008?
Offer a terse response. 0.87. What is the ratio of the Internet users (% of population) in Thailand in 2006 to that in 2008?
Your answer should be very brief. 0.94. What is the ratio of the Internet users (% of population) of Yemen, Rep. in 2006 to that in 2008?
Provide a succinct answer. 0.18. What is the ratio of the Internet users (% of population) of Kenya in 2006 to that in 2009?
Make the answer very short. 0.75. What is the ratio of the Internet users (% of population) in Thailand in 2006 to that in 2009?
Your answer should be compact. 0.85. What is the ratio of the Internet users (% of population) in Yemen, Rep. in 2006 to that in 2009?
Make the answer very short. 0.13. What is the ratio of the Internet users (% of population) of Kenya in 2007 to that in 2008?
Your response must be concise. 0.92. What is the ratio of the Internet users (% of population) in Thailand in 2007 to that in 2008?
Provide a succinct answer. 1.1. What is the ratio of the Internet users (% of population) in Yemen, Rep. in 2007 to that in 2008?
Provide a succinct answer. 0.73. What is the ratio of the Internet users (% of population) of Kenya in 2007 to that in 2009?
Your answer should be compact. 0.79. What is the ratio of the Internet users (% of population) of Thailand in 2007 to that in 2009?
Give a very brief answer. 1. What is the ratio of the Internet users (% of population) of Yemen, Rep. in 2007 to that in 2009?
Ensure brevity in your answer.  0.5. What is the ratio of the Internet users (% of population) of Kenya in 2008 to that in 2009?
Keep it short and to the point. 0.86. What is the ratio of the Internet users (% of population) in Thailand in 2008 to that in 2009?
Offer a very short reply. 0.91. What is the ratio of the Internet users (% of population) of Yemen, Rep. in 2008 to that in 2009?
Offer a very short reply. 0.69. What is the difference between the highest and the second highest Internet users (% of population) in Kenya?
Ensure brevity in your answer.  1.37. What is the difference between the highest and the second highest Internet users (% of population) in Thailand?
Offer a very short reply. 0.07. What is the difference between the highest and the second highest Internet users (% of population) in Yemen, Rep.?
Your response must be concise. 3.07. What is the difference between the highest and the lowest Internet users (% of population) in Kenya?
Give a very brief answer. 8.83. What is the difference between the highest and the lowest Internet users (% of population) in Thailand?
Offer a very short reply. 12.57. What is the difference between the highest and the lowest Internet users (% of population) in Yemen, Rep.?
Ensure brevity in your answer.  9.44. 